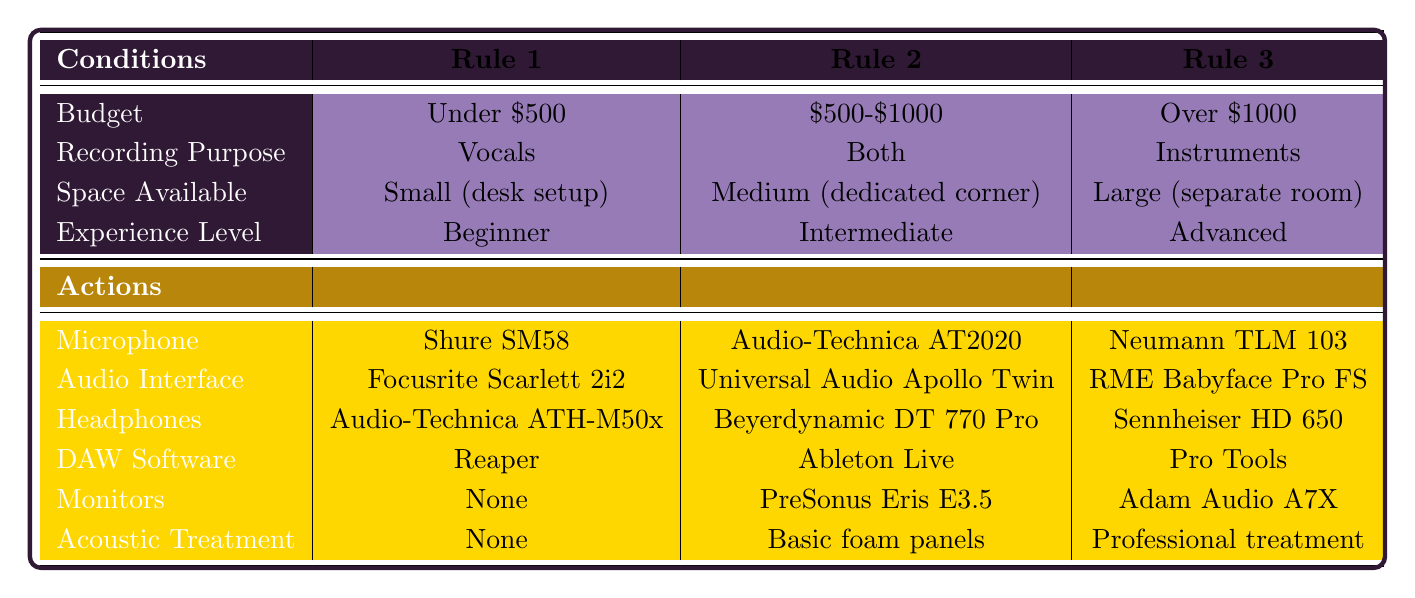What microphone is recommended for a beginner on a budget under $500? According to the table, for the condition of being a beginner and having a budget under $500, the recommended microphone is the Shure SM58.
Answer: Shure SM58 Which audio interface is suggested for intermediate users who want to record both vocals and instruments? The table shows that for intermediate users looking to record both, the suggested audio interface is the Universal Audio Apollo Twin.
Answer: Universal Audio Apollo Twin Is the Beyerdynamic DT 770 Pro also suitable if the recording setup is intended for small spaces? The table doesn't provide a recommendation for Beyerdynamic DT 770 Pro in a small (desk setup) recording space; it is recommended for medium space. Hence, it is not suitable.
Answer: No What is the only DAW software recommendation for advanced users with an over $1000 budget focused on instruments? The table indicates that the only DAW software for advanced users with a budget over $1000 focusing on instruments is Pro Tools.
Answer: Pro Tools If someone has a medium-sized space and a budget of $500-$1000, what action is recommended for acoustic treatment? According to the table for medium space with a budget of $500-$1000, the recommended action for acoustic treatment is Basic foam panels.
Answer: Basic foam panels What is the total number of different headphones options available across all budget levels? The table lists three headphones options for each of the three rules and does not repeat any entries. Thus, the total number of different headphone options is 3 (Audio-Technica ATH-M50x, Beyerdynamic DT 770 Pro, Sennheiser HD 650).
Answer: 3 Could you identify any recommended equipment if the budget is under $500 but the recording purpose is instruments instead of vocals? The table does not provide any recommendations for instruments under a $500 budget; it only lists rules for vocals. So, there are no recommendations that fulfill the criteria.
Answer: No Which monitors are recommended for someone with an over $1000 budget who is focused on instruments? It can be found in the table that for someone with a budget over $1000 focusing on instruments, the recommended monitors are Adam Audio A7X.
Answer: Adam Audio A7X 